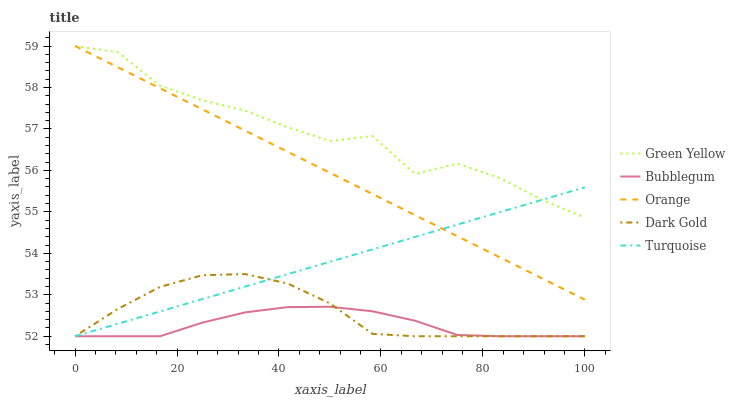Does Turquoise have the minimum area under the curve?
Answer yes or no. No. Does Turquoise have the maximum area under the curve?
Answer yes or no. No. Is Turquoise the smoothest?
Answer yes or no. No. Is Turquoise the roughest?
Answer yes or no. No. Does Green Yellow have the lowest value?
Answer yes or no. No. Does Turquoise have the highest value?
Answer yes or no. No. Is Dark Gold less than Green Yellow?
Answer yes or no. Yes. Is Green Yellow greater than Dark Gold?
Answer yes or no. Yes. Does Dark Gold intersect Green Yellow?
Answer yes or no. No. 